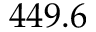Convert formula to latex. <formula><loc_0><loc_0><loc_500><loc_500>4 4 9 . 6</formula> 